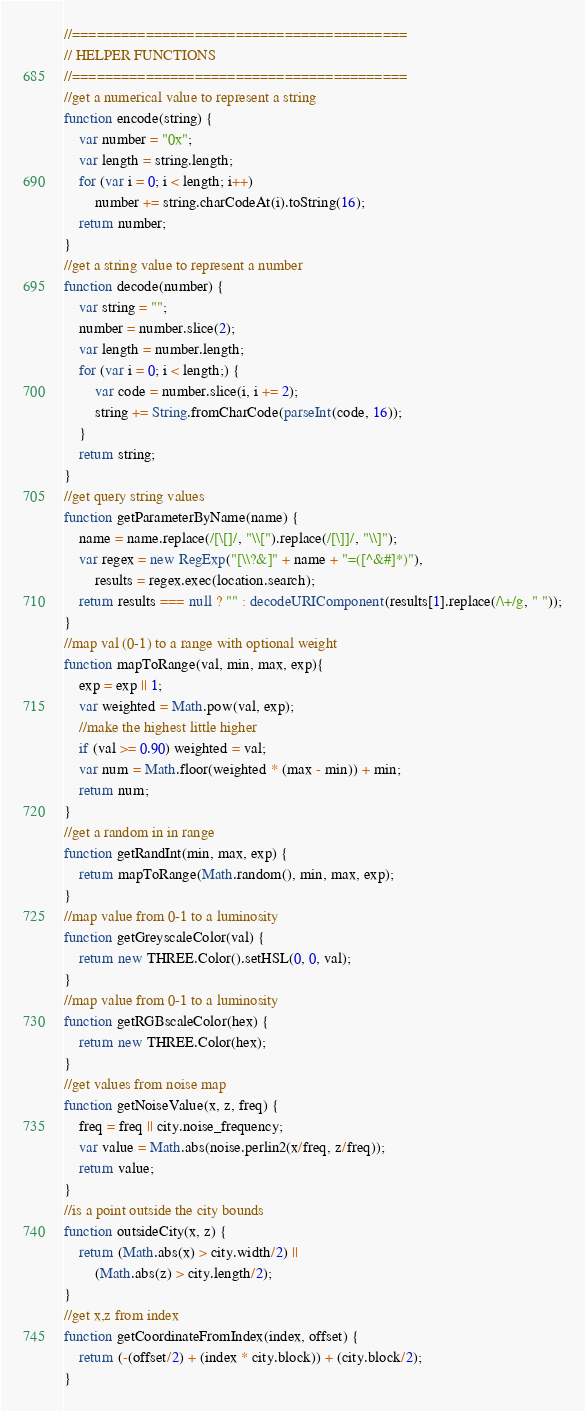<code> <loc_0><loc_0><loc_500><loc_500><_JavaScript_>//=========================================
// HELPER FUNCTIONS
//=========================================
//get a numerical value to represent a string
function encode(string) {
    var number = "0x";
    var length = string.length;
    for (var i = 0; i < length; i++)
        number += string.charCodeAt(i).toString(16);
    return number;
}
//get a string value to represent a number
function decode(number) {
    var string = "";
    number = number.slice(2);
    var length = number.length;
    for (var i = 0; i < length;) {
        var code = number.slice(i, i += 2);
        string += String.fromCharCode(parseInt(code, 16));
    }
    return string;
}
//get query string values
function getParameterByName(name) {
    name = name.replace(/[\[]/, "\\[").replace(/[\]]/, "\\]");
    var regex = new RegExp("[\\?&]" + name + "=([^&#]*)"),
        results = regex.exec(location.search);
    return results === null ? "" : decodeURIComponent(results[1].replace(/\+/g, " "));
}
//map val (0-1) to a range with optional weight
function mapToRange(val, min, max, exp){
	exp = exp || 1;
	var weighted = Math.pow(val, exp);
	//make the highest little higher
	if (val >= 0.90) weighted = val;
	var num = Math.floor(weighted * (max - min)) + min;
	return num;
}
//get a random in in range
function getRandInt(min, max, exp) {
	return mapToRange(Math.random(), min, max, exp);
}
//map value from 0-1 to a luminosity
function getGreyscaleColor(val) {
	return new THREE.Color().setHSL(0, 0, val);
}
//map value from 0-1 to a luminosity
function getRGBscaleColor(hex) {
	return new THREE.Color(hex);
}
//get values from noise map
function getNoiseValue(x, z, freq) {
	freq = freq || city.noise_frequency;
	var value = Math.abs(noise.perlin2(x/freq, z/freq));
	return value;
}
//is a point outside the city bounds
function outsideCity(x, z) {
	return (Math.abs(x) > city.width/2) ||
		(Math.abs(z) > city.length/2);
}
//get x,z from index
function getCoordinateFromIndex(index, offset) {
	return (-(offset/2) + (index * city.block)) + (city.block/2);
}</code> 